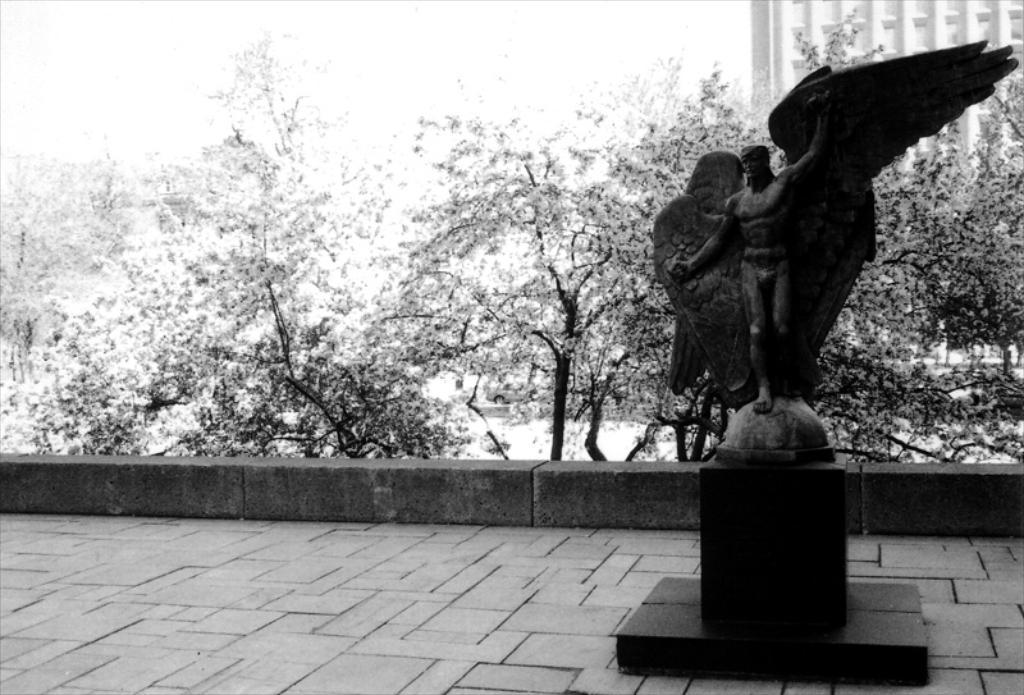Please provide a concise description of this image. This picture is clicked outside the city. Here, we see a statue of man standing on pillar with wings open. Behind that, we see many trees and behind trees, we see a building which is white in color and this is a black and white picture. 